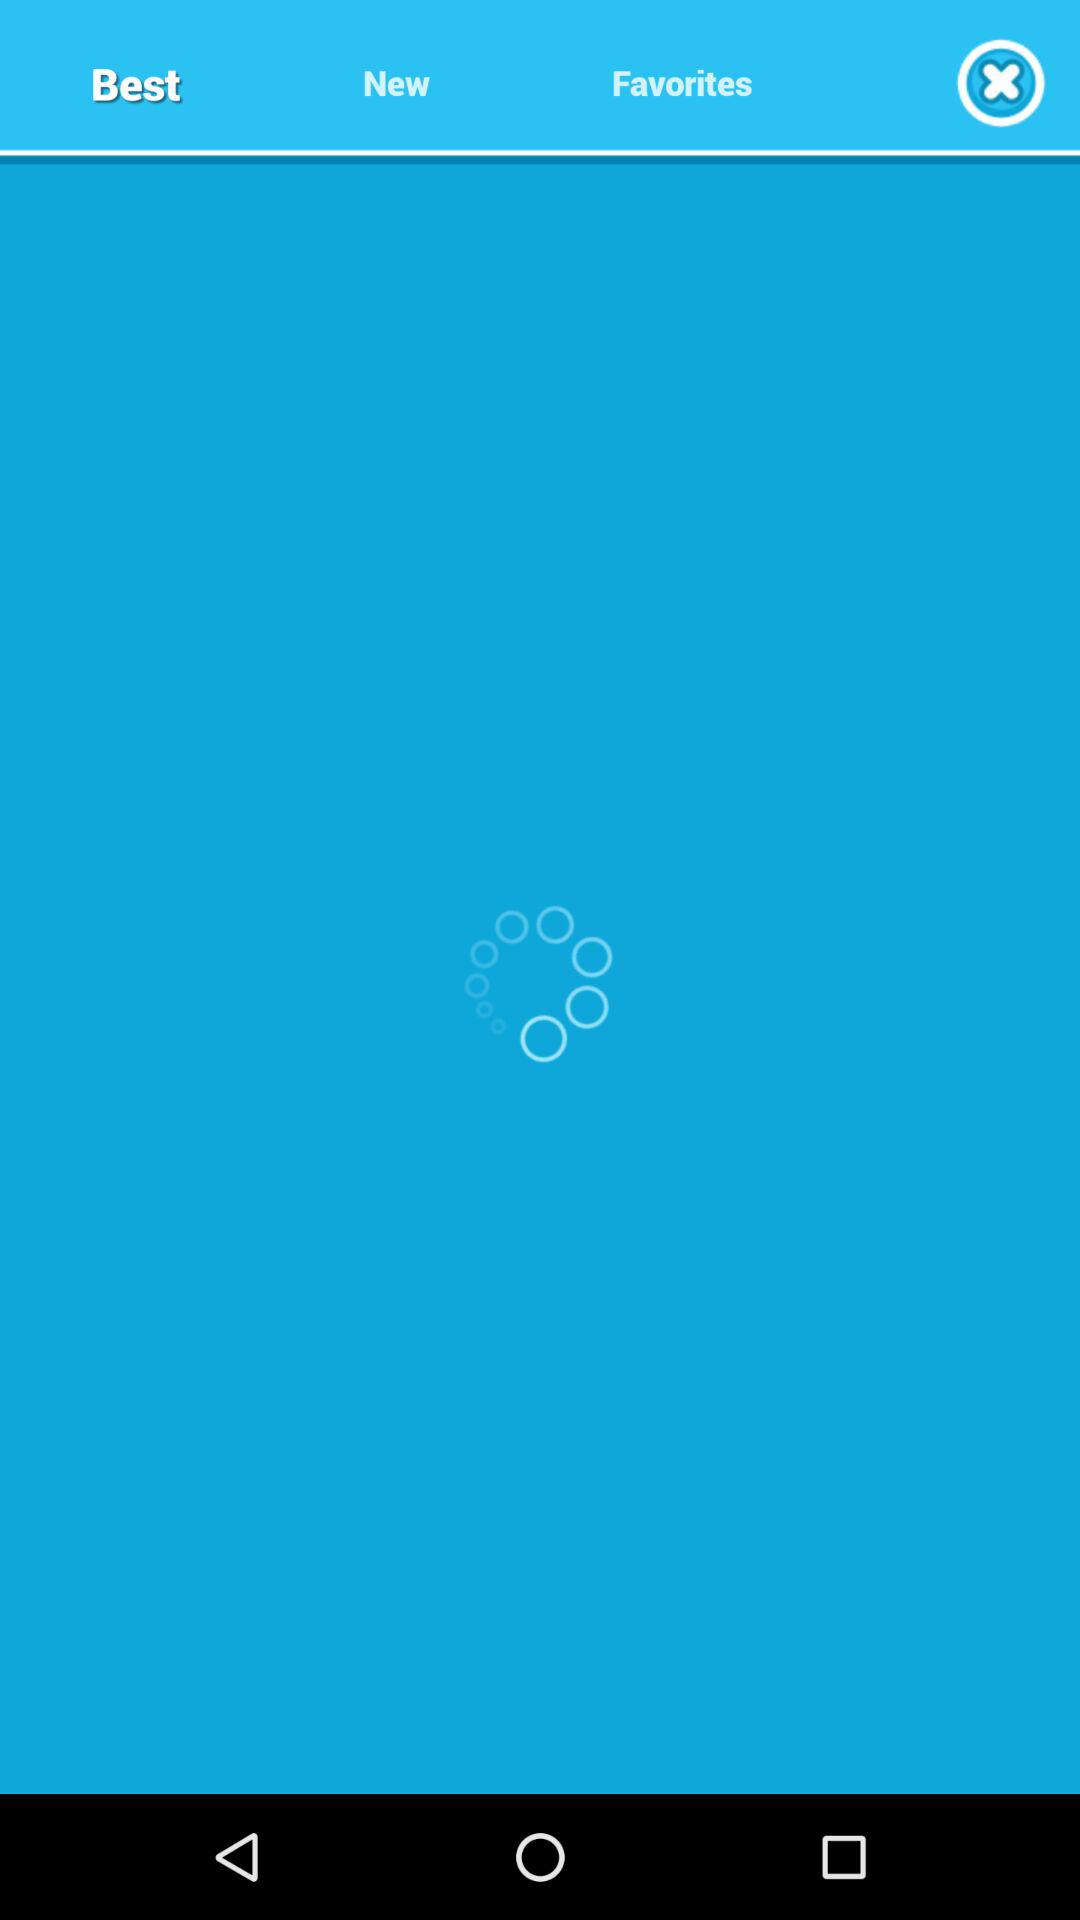Which tab is selected? The selected tab is Best. 